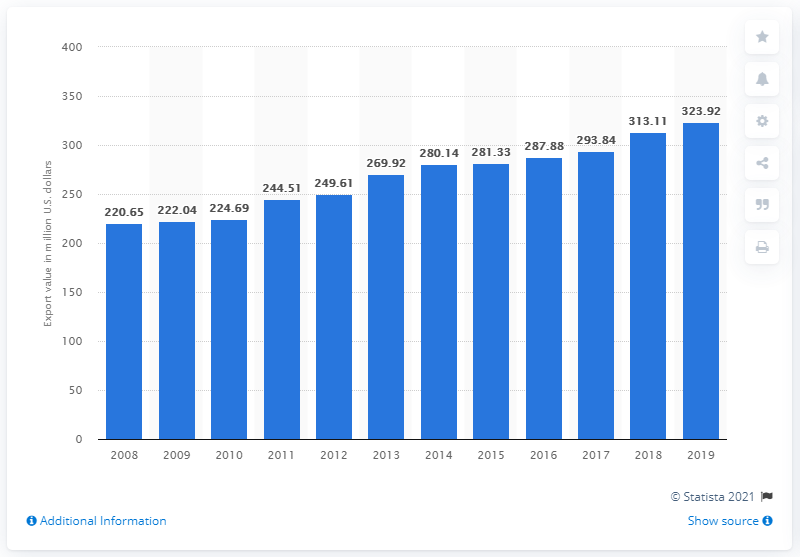Highlight a few significant elements in this photo. In 2019, the value of maple exports from Canada was $323.92 million in dollars. 